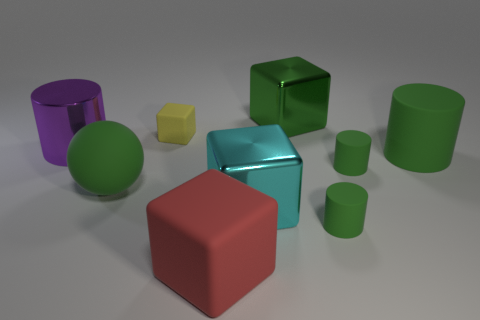Subtract all green blocks. How many green cylinders are left? 3 Add 1 brown cylinders. How many objects exist? 10 Subtract all cubes. How many objects are left? 5 Subtract all cyan shiny things. Subtract all red objects. How many objects are left? 7 Add 9 large red matte cubes. How many large red matte cubes are left? 10 Add 3 big red things. How many big red things exist? 4 Subtract 0 cyan cylinders. How many objects are left? 9 